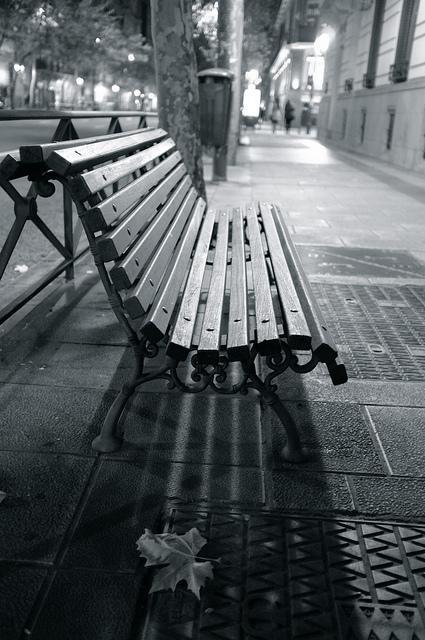How many dolphins are painted on the boats in this photo?
Give a very brief answer. 0. 